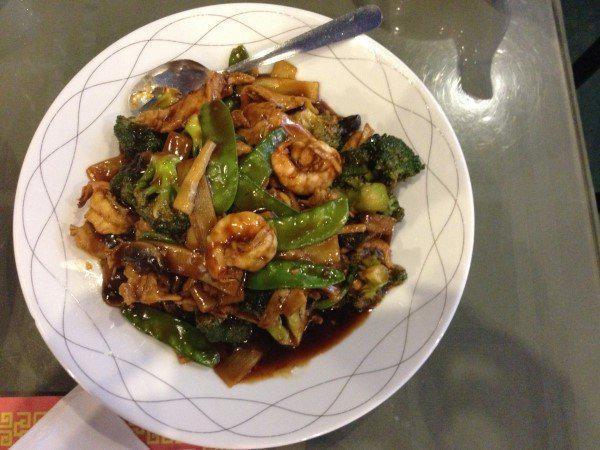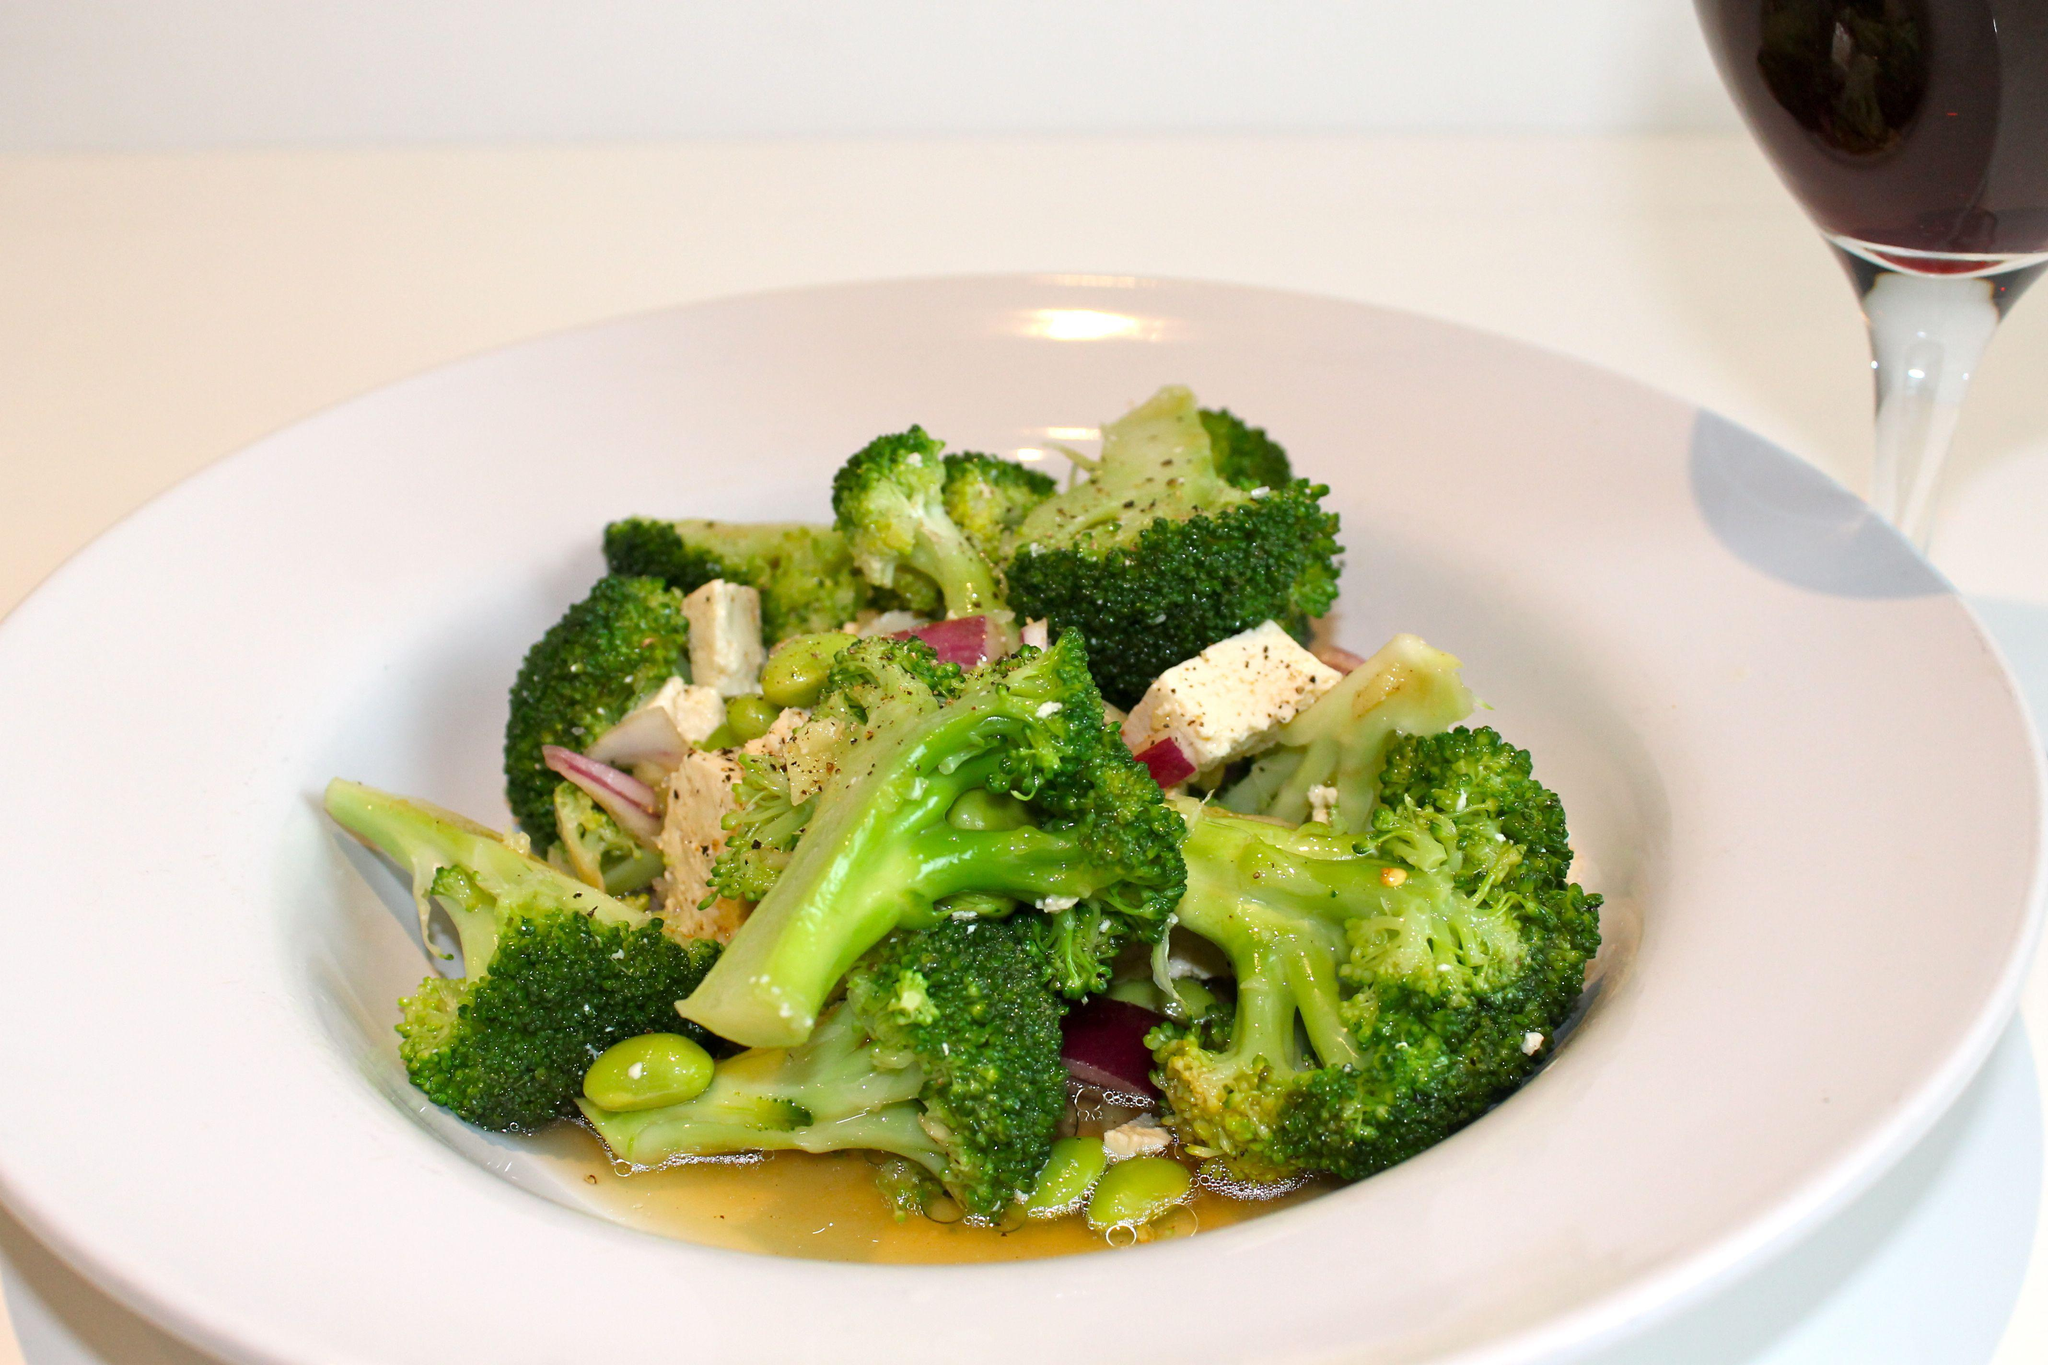The first image is the image on the left, the second image is the image on the right. Given the left and right images, does the statement "At least one image shows a broccoli dish served on an all white plate, with no colored trim." hold true? Answer yes or no. Yes. The first image is the image on the left, the second image is the image on the right. Analyze the images presented: Is the assertion "There is rice in the image on the right." valid? Answer yes or no. No. 